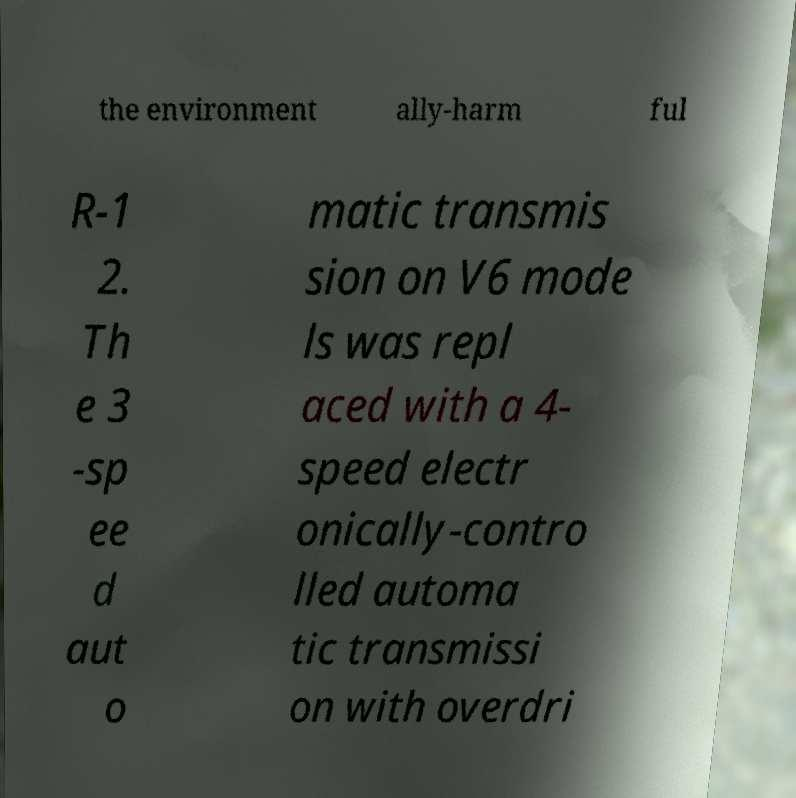For documentation purposes, I need the text within this image transcribed. Could you provide that? the environment ally-harm ful R-1 2. Th e 3 -sp ee d aut o matic transmis sion on V6 mode ls was repl aced with a 4- speed electr onically-contro lled automa tic transmissi on with overdri 